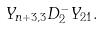<formula> <loc_0><loc_0><loc_500><loc_500>Y _ { n + 3 , 3 } D _ { 2 } ^ { - } Y _ { 2 1 } .</formula> 